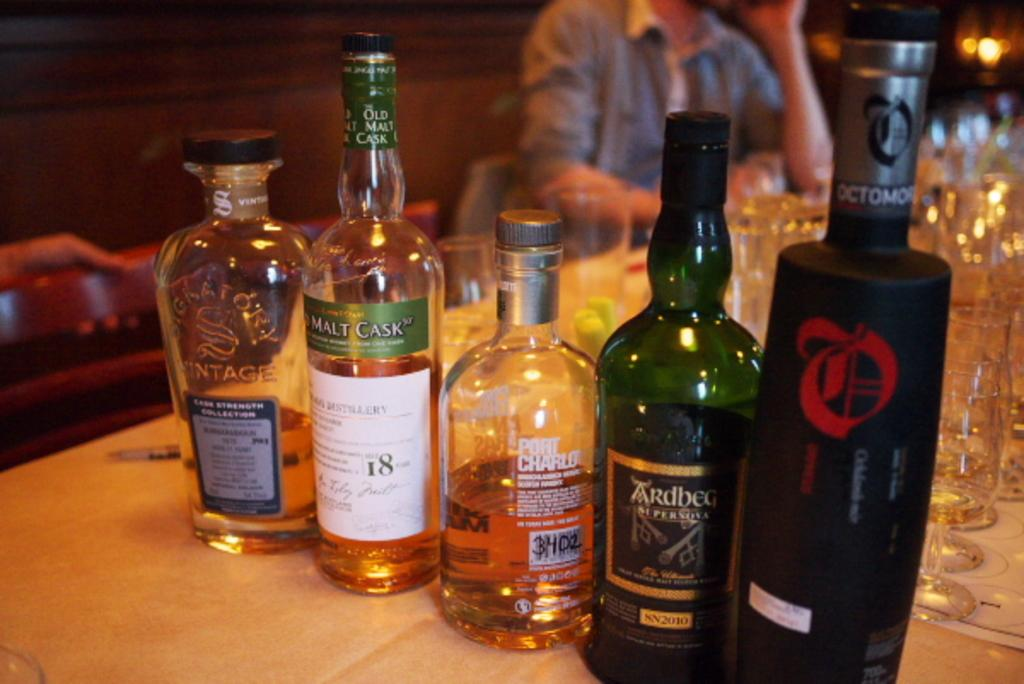<image>
Write a terse but informative summary of the picture. Bottle of alcohol on a table, one of which is labelled malt cast 